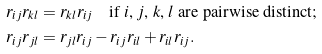<formula> <loc_0><loc_0><loc_500><loc_500>r _ { i j } r _ { k l } & = r _ { k l } r _ { i j } \quad \text {if $i$, $j$, $k$, $l$ are pairwise distinct} ; \\ r _ { i j } r _ { j l } & = r _ { j l } r _ { i j } - r _ { i j } r _ { i l } + r _ { i l } r _ { i j } .</formula> 